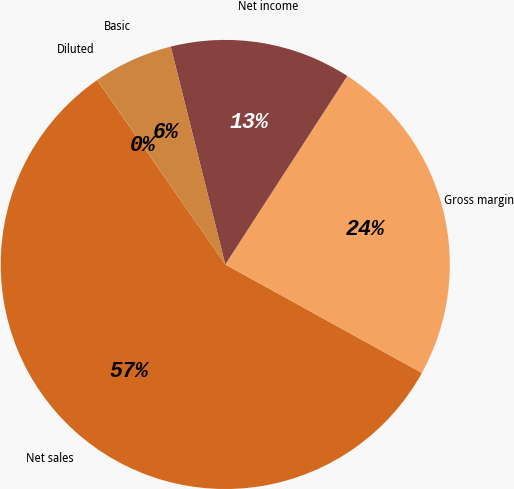Convert chart to OTSL. <chart><loc_0><loc_0><loc_500><loc_500><pie_chart><fcel>Net sales<fcel>Gross margin<fcel>Net income<fcel>Basic<fcel>Diluted<nl><fcel>57.31%<fcel>23.88%<fcel>13.05%<fcel>5.74%<fcel>0.01%<nl></chart> 